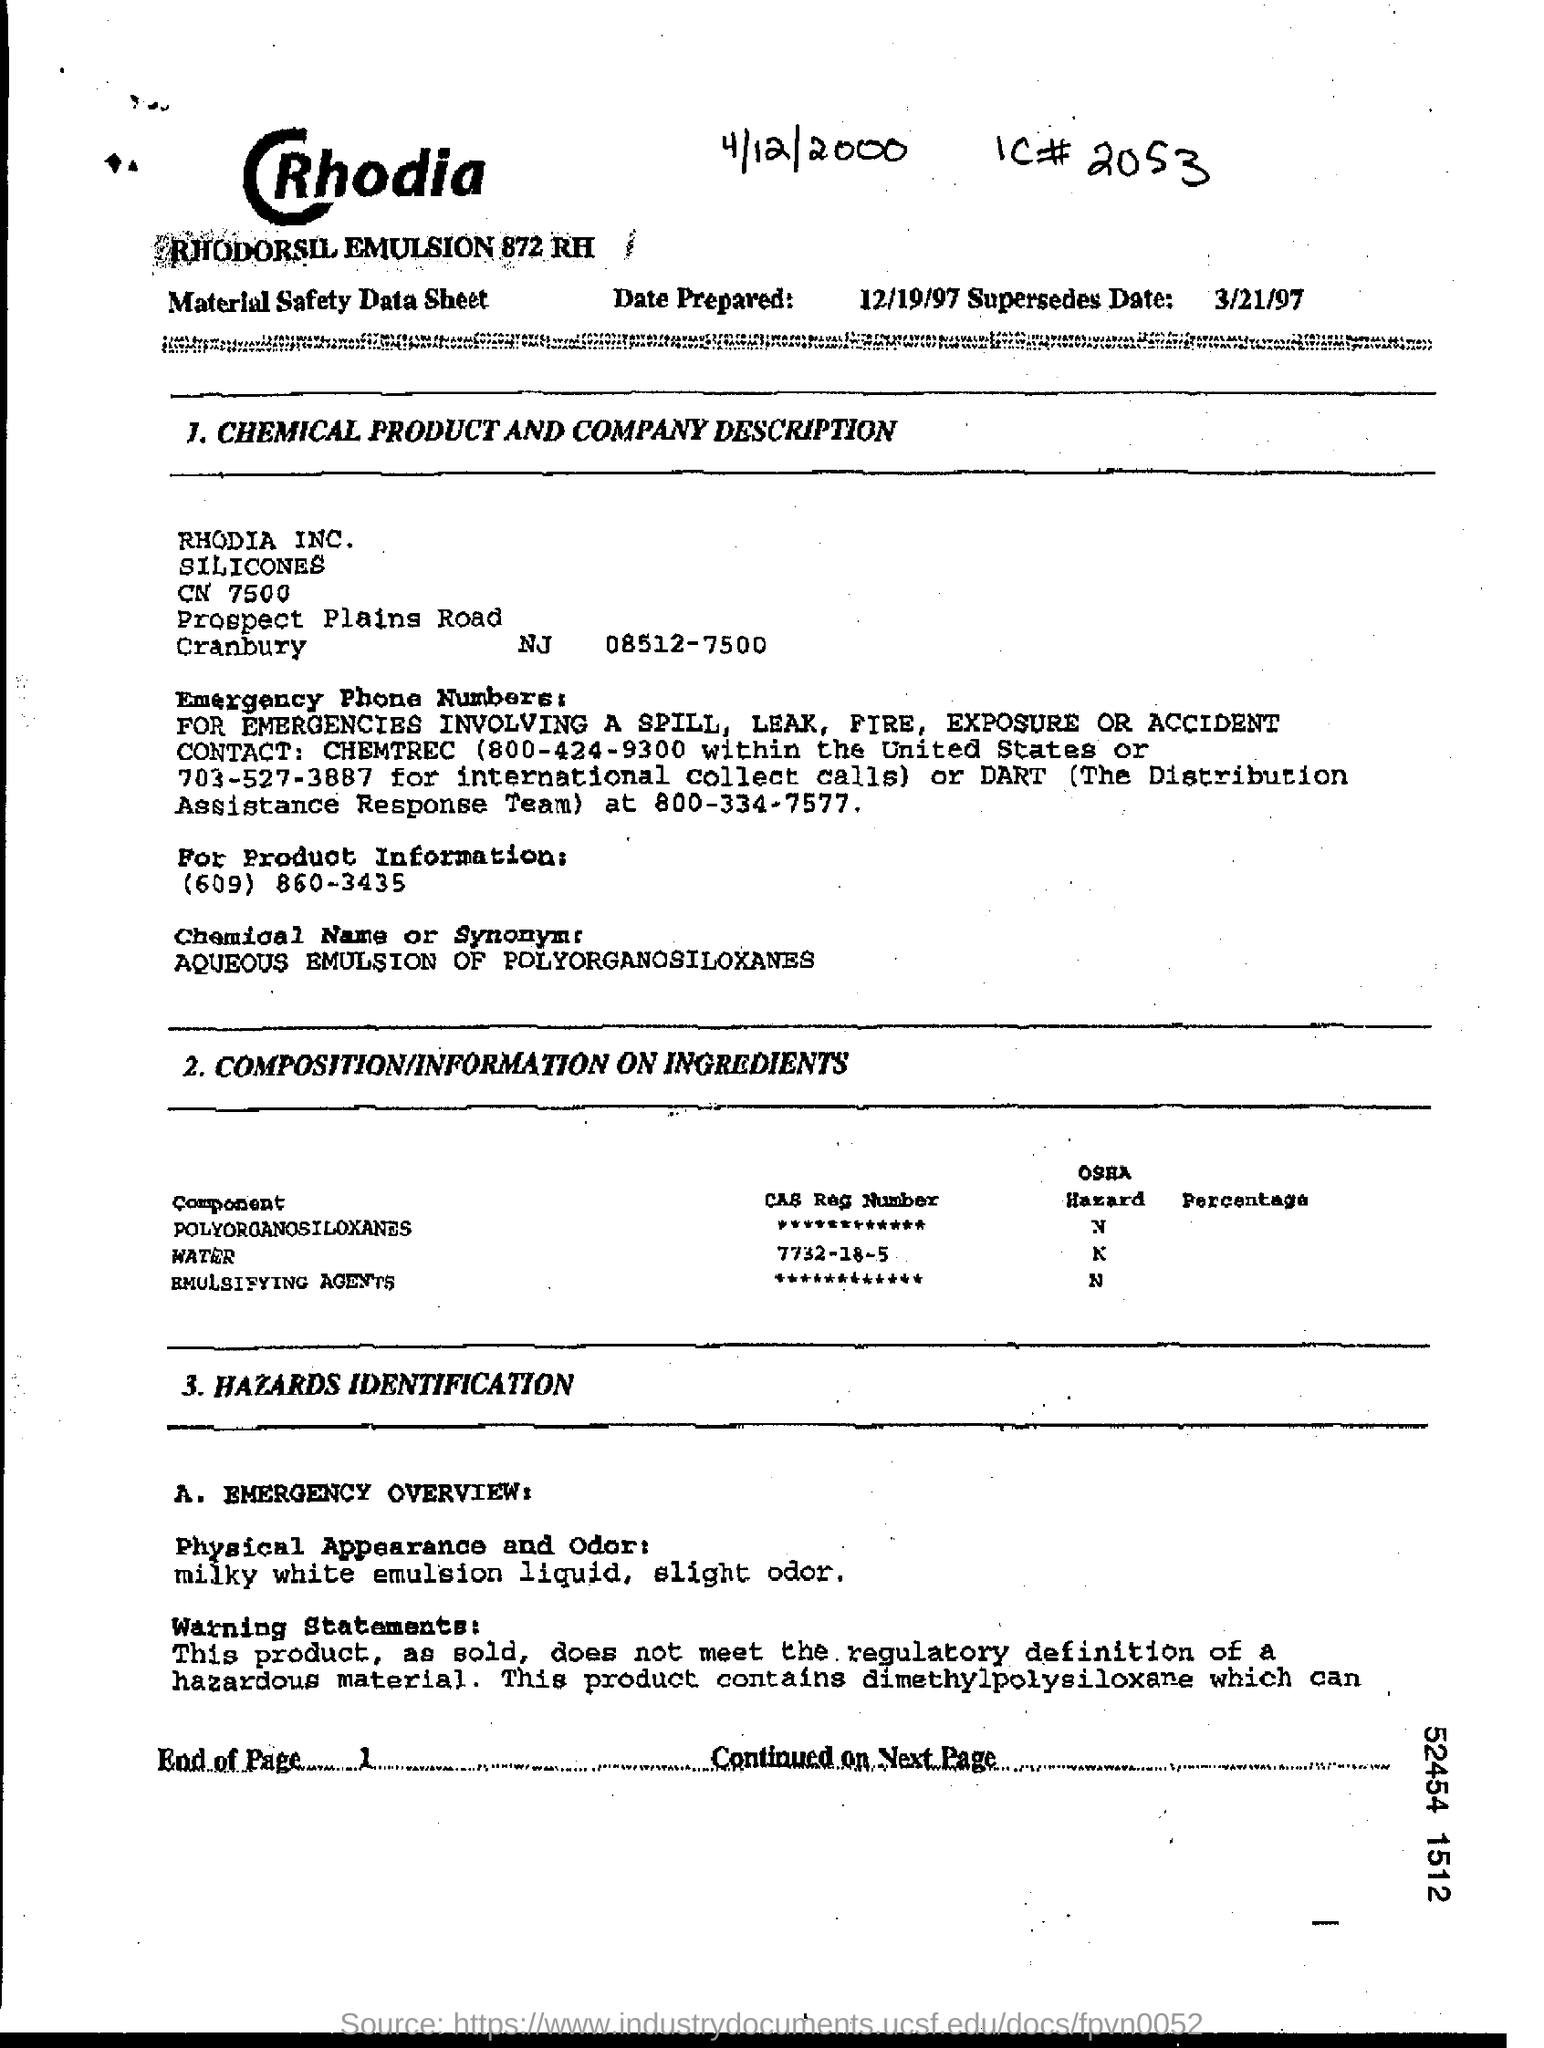What is IC#
Ensure brevity in your answer.  2053. 